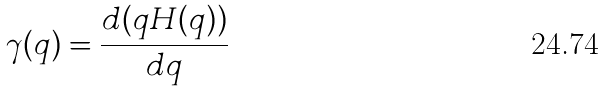<formula> <loc_0><loc_0><loc_500><loc_500>\gamma ( q ) = \frac { d ( q H ( q ) ) } { d q }</formula> 